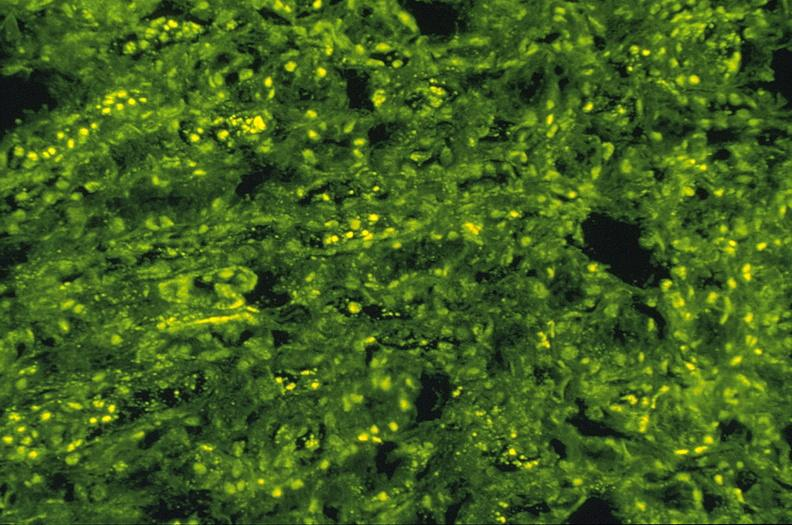what is present?
Answer the question using a single word or phrase. Urinary 